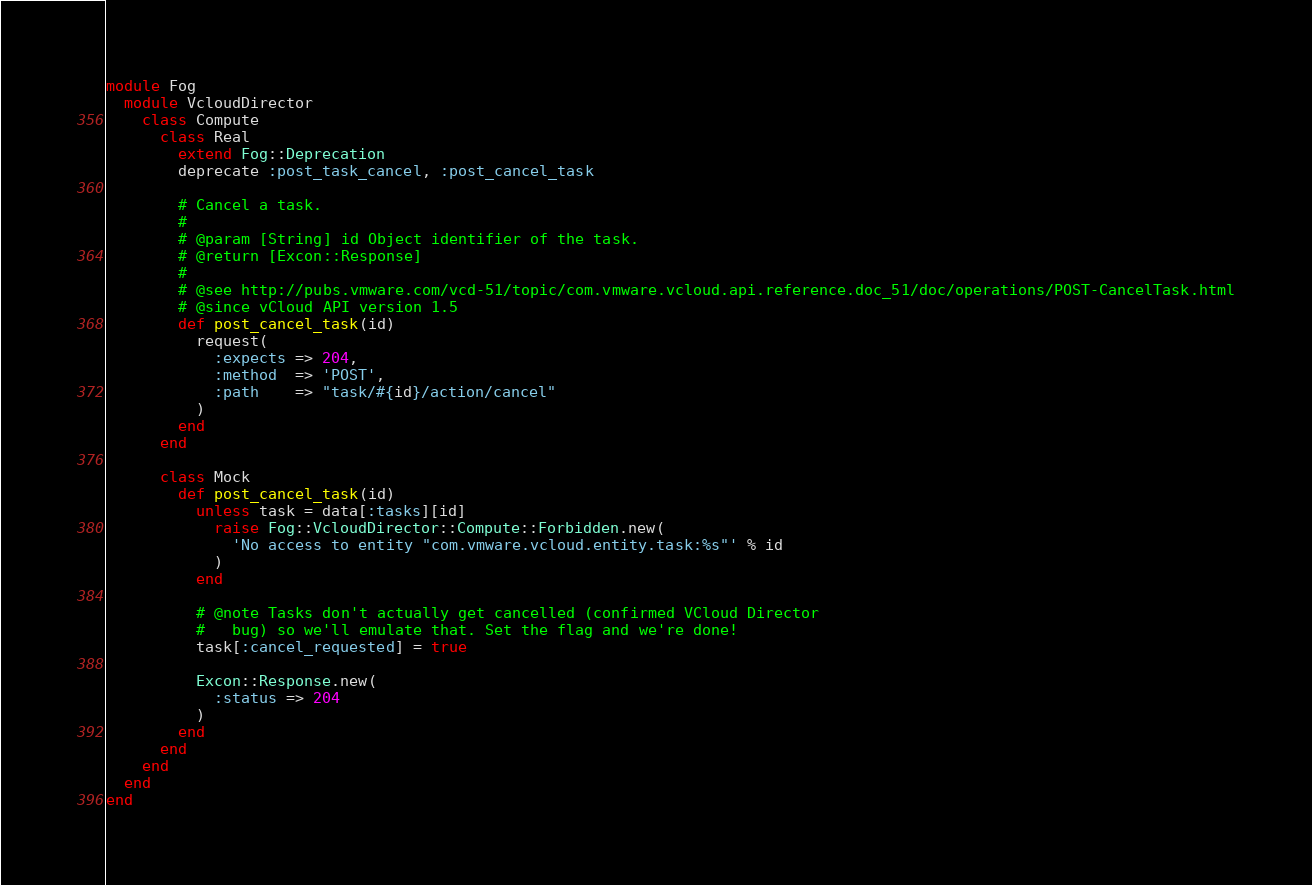<code> <loc_0><loc_0><loc_500><loc_500><_Ruby_>module Fog
  module VcloudDirector
    class Compute
      class Real
        extend Fog::Deprecation
        deprecate :post_task_cancel, :post_cancel_task

        # Cancel a task.
        #
        # @param [String] id Object identifier of the task.
        # @return [Excon::Response]
        #
        # @see http://pubs.vmware.com/vcd-51/topic/com.vmware.vcloud.api.reference.doc_51/doc/operations/POST-CancelTask.html
        # @since vCloud API version 1.5
        def post_cancel_task(id)
          request(
            :expects => 204,
            :method  => 'POST',
            :path    => "task/#{id}/action/cancel"
          )
        end
      end

      class Mock
        def post_cancel_task(id)
          unless task = data[:tasks][id]
            raise Fog::VcloudDirector::Compute::Forbidden.new(
              'No access to entity "com.vmware.vcloud.entity.task:%s"' % id
            )
          end

          # @note Tasks don't actually get cancelled (confirmed VCloud Director
          #   bug) so we'll emulate that. Set the flag and we're done!
          task[:cancel_requested] = true

          Excon::Response.new(
            :status => 204
          )
        end
      end
    end
  end
end
</code> 